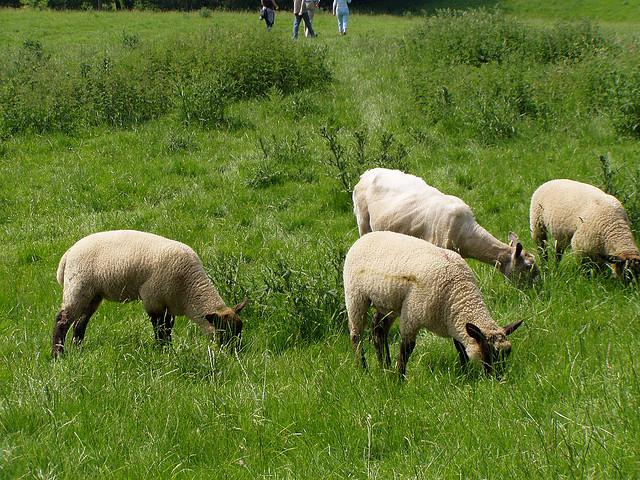How many species are in this image? one 